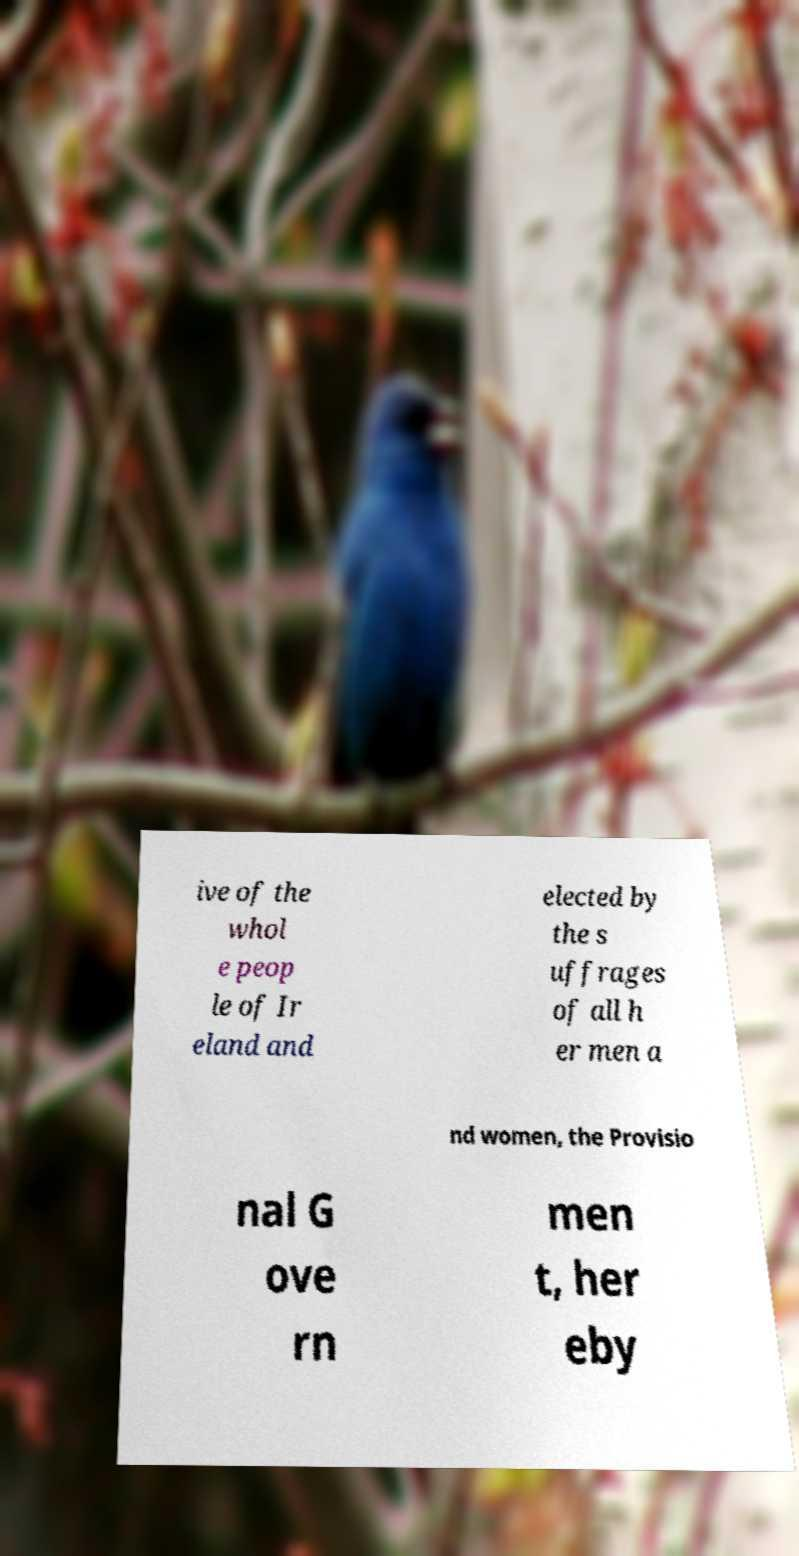There's text embedded in this image that I need extracted. Can you transcribe it verbatim? ive of the whol e peop le of Ir eland and elected by the s uffrages of all h er men a nd women, the Provisio nal G ove rn men t, her eby 